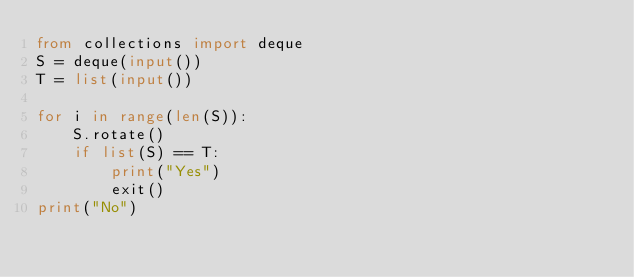<code> <loc_0><loc_0><loc_500><loc_500><_Python_>from collections import deque
S = deque(input())
T = list(input())

for i in range(len(S)):
    S.rotate()
    if list(S) == T:
        print("Yes")
        exit()
print("No")</code> 